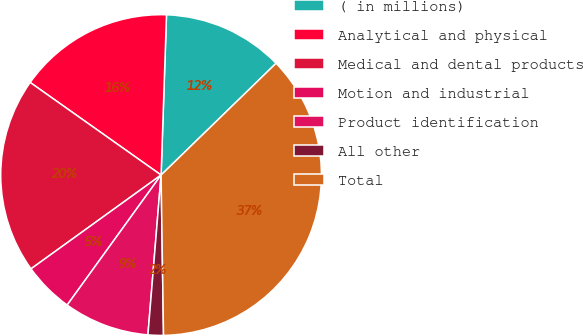<chart> <loc_0><loc_0><loc_500><loc_500><pie_chart><fcel>( in millions)<fcel>Analytical and physical<fcel>Medical and dental products<fcel>Motion and industrial<fcel>Product identification<fcel>All other<fcel>Total<nl><fcel>12.19%<fcel>15.74%<fcel>19.74%<fcel>5.1%<fcel>8.65%<fcel>1.55%<fcel>37.03%<nl></chart> 